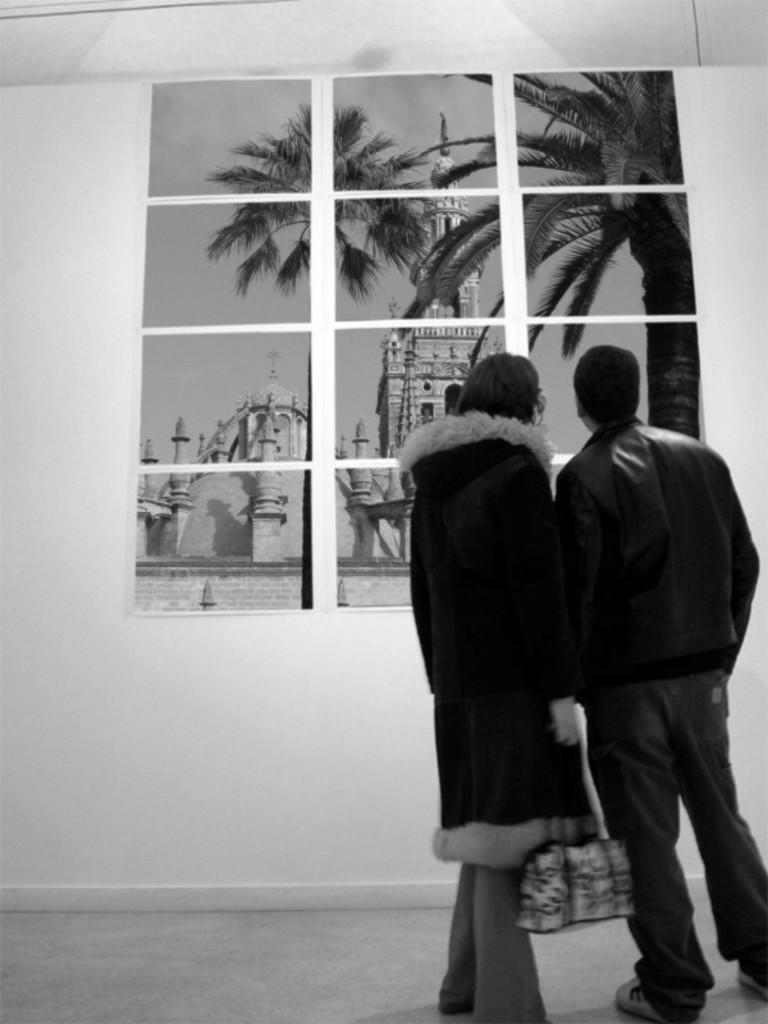Please provide a concise description of this image. In this image we can see there are two people standing and there is the person holding a bag. In front of them, we can see the wall with images. 